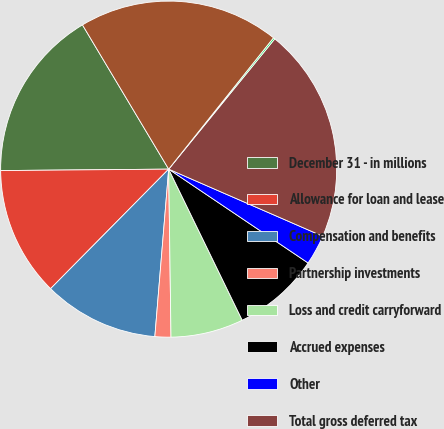Convert chart to OTSL. <chart><loc_0><loc_0><loc_500><loc_500><pie_chart><fcel>December 31 - in millions<fcel>Allowance for loan and lease<fcel>Compensation and benefits<fcel>Partnership investments<fcel>Loss and credit carryforward<fcel>Accrued expenses<fcel>Other<fcel>Total gross deferred tax<fcel>Valuation allowance<fcel>Total deferred tax assets<nl><fcel>16.56%<fcel>12.46%<fcel>11.09%<fcel>1.53%<fcel>6.99%<fcel>8.36%<fcel>2.89%<fcel>20.66%<fcel>0.16%<fcel>19.29%<nl></chart> 